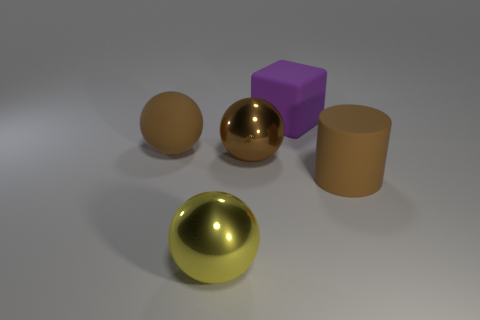What is the material of the brown cylinder that is the same size as the block?
Provide a short and direct response. Rubber. What shape is the yellow object that is the same size as the rubber block?
Keep it short and to the point. Sphere. There is a metal object that is to the right of the yellow thing; is its shape the same as the large rubber thing to the left of the rubber block?
Make the answer very short. Yes. Is the sphere behind the brown shiny ball made of the same material as the yellow sphere?
Provide a succinct answer. No. Is the number of brown rubber objects to the left of the purple cube greater than the number of brown matte cylinders in front of the cylinder?
Ensure brevity in your answer.  Yes. How many things are either things to the right of the big rubber cube or brown metallic spheres?
Your response must be concise. 2. What shape is the large thing that is made of the same material as the large yellow sphere?
Your answer should be compact. Sphere. Is there any other thing that is the same shape as the large purple thing?
Provide a short and direct response. No. There is a object that is both right of the yellow sphere and on the left side of the large rubber block; what is its color?
Make the answer very short. Brown. How many cylinders are either purple rubber objects or large yellow objects?
Your answer should be compact. 0. 